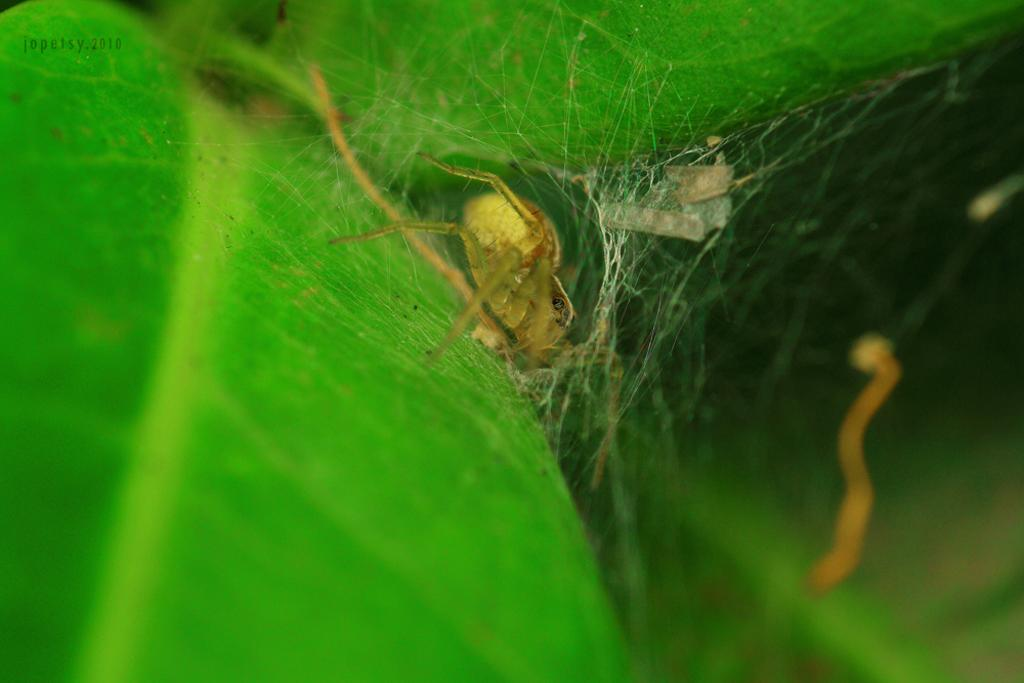What is the main subject in the center of the image? There is a spider in the center of the image. What is associated with the spider in the image? There is a spider web in the center of the image. What can be seen in the background of the image? There is a plant in the background of the image. What type of tray is being used by the spy in the image? There is no tray or spy present in the image; it features a spider and a spider web. What discovery has the spider made in the image? There is no indication of a discovery in the image; it simply shows a spider and a spider web. 